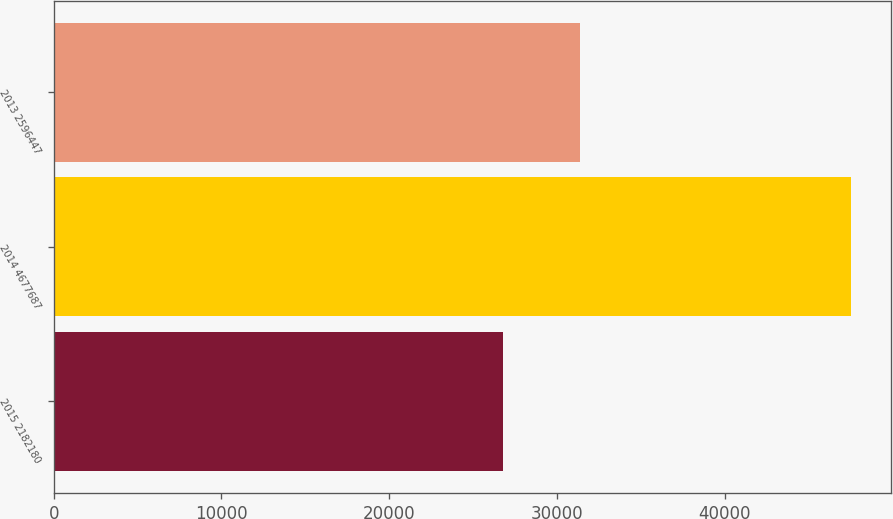<chart> <loc_0><loc_0><loc_500><loc_500><bar_chart><fcel>2015 2182180<fcel>2014 4677687<fcel>2013 2596447<nl><fcel>26751<fcel>47545.9<fcel>31349.5<nl></chart> 